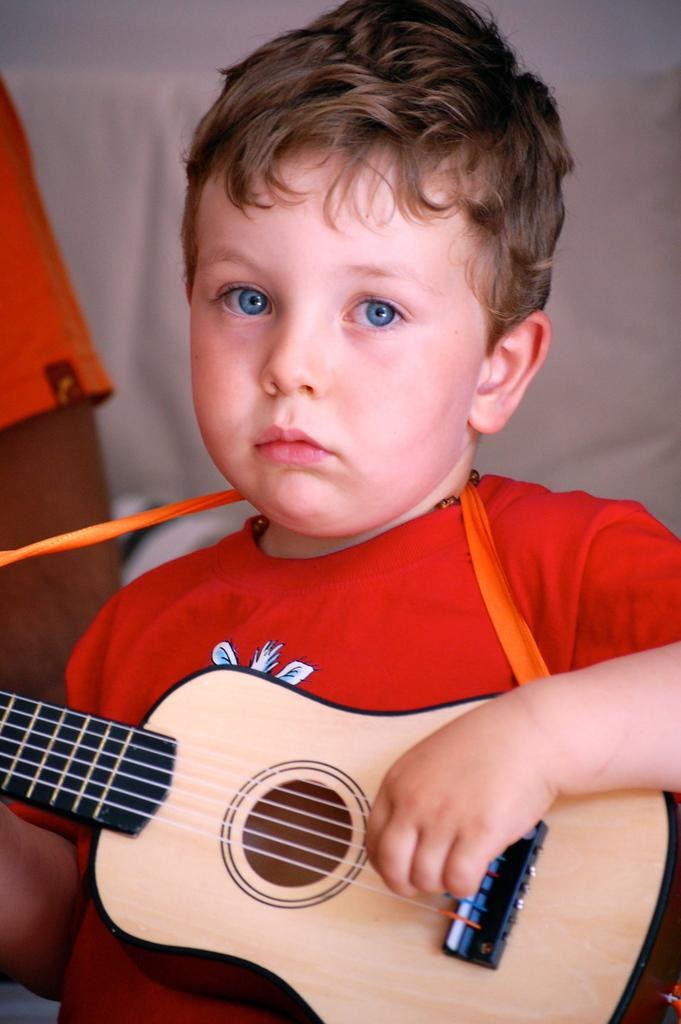What is the main subject of the image? The main subject of the image is a boy. What is the boy holding in the image? The boy is holding a guitar. What level of hearing does the boy have in the image? There is no information about the boy's hearing in the image, so it cannot be determined. 